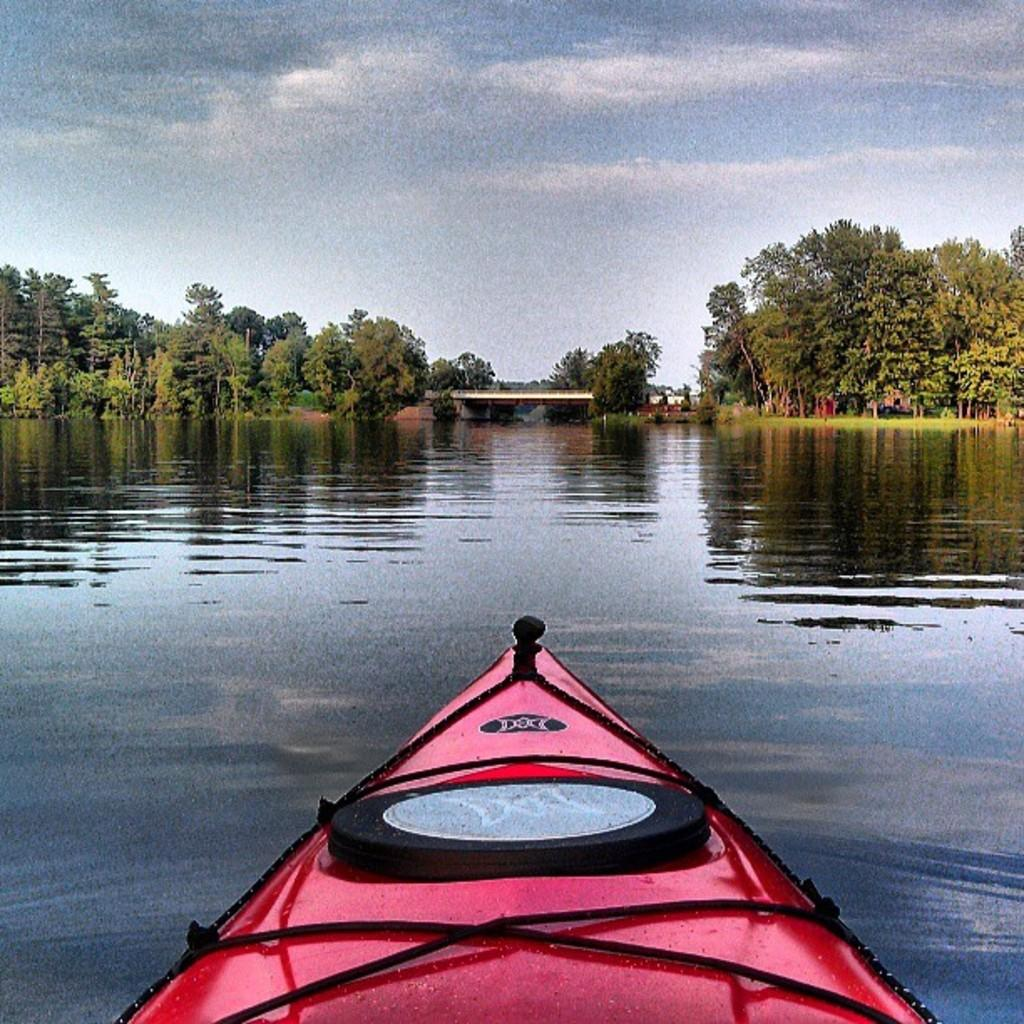What is the main subject of the image? The main subject of the image is a boat. Where is the boat located? The boat is on the water. What can be seen in the background of the image? There are trees, a bridge, and the sky visible in the background of the image. What type of card is being used to poison the monkey in the image? There is no card, poison, or monkey present in the image. 